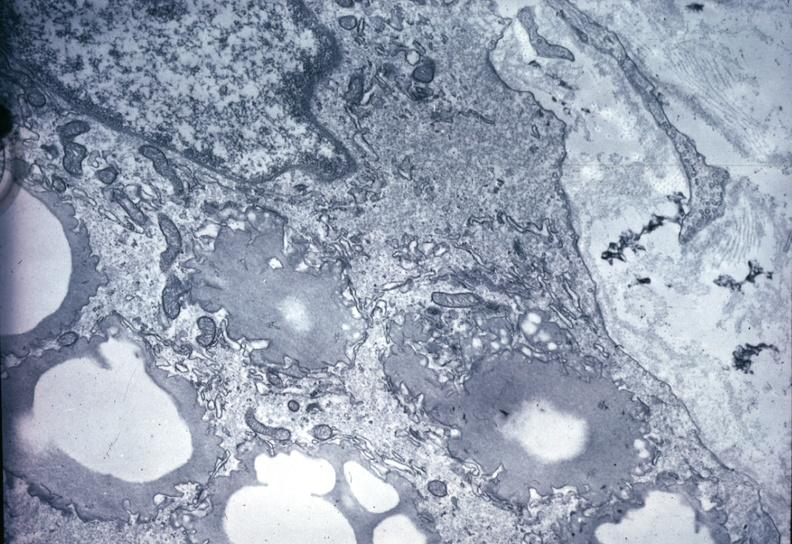do this image shows of smooth muscle cell with lipid in sarcoplasm and lipid precipitate in interstitial space very good example outside case?
Answer the question using a single word or phrase. Yes 